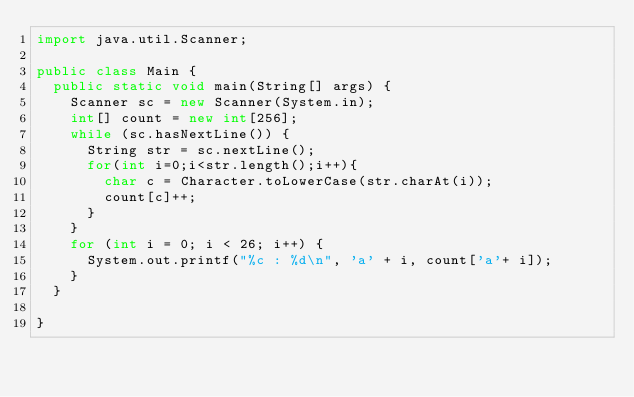<code> <loc_0><loc_0><loc_500><loc_500><_Java_>import java.util.Scanner;

public class Main {
	public static void main(String[] args) {
		Scanner sc = new Scanner(System.in);
		int[] count = new int[256];
		while (sc.hasNextLine()) {
			String str = sc.nextLine();
			for(int i=0;i<str.length();i++){
				char c = Character.toLowerCase(str.charAt(i));
				count[c]++;
			}
		}
		for (int i = 0; i < 26; i++) {
			System.out.printf("%c : %d\n", 'a' + i, count['a'+ i]);
		}
	}

}</code> 